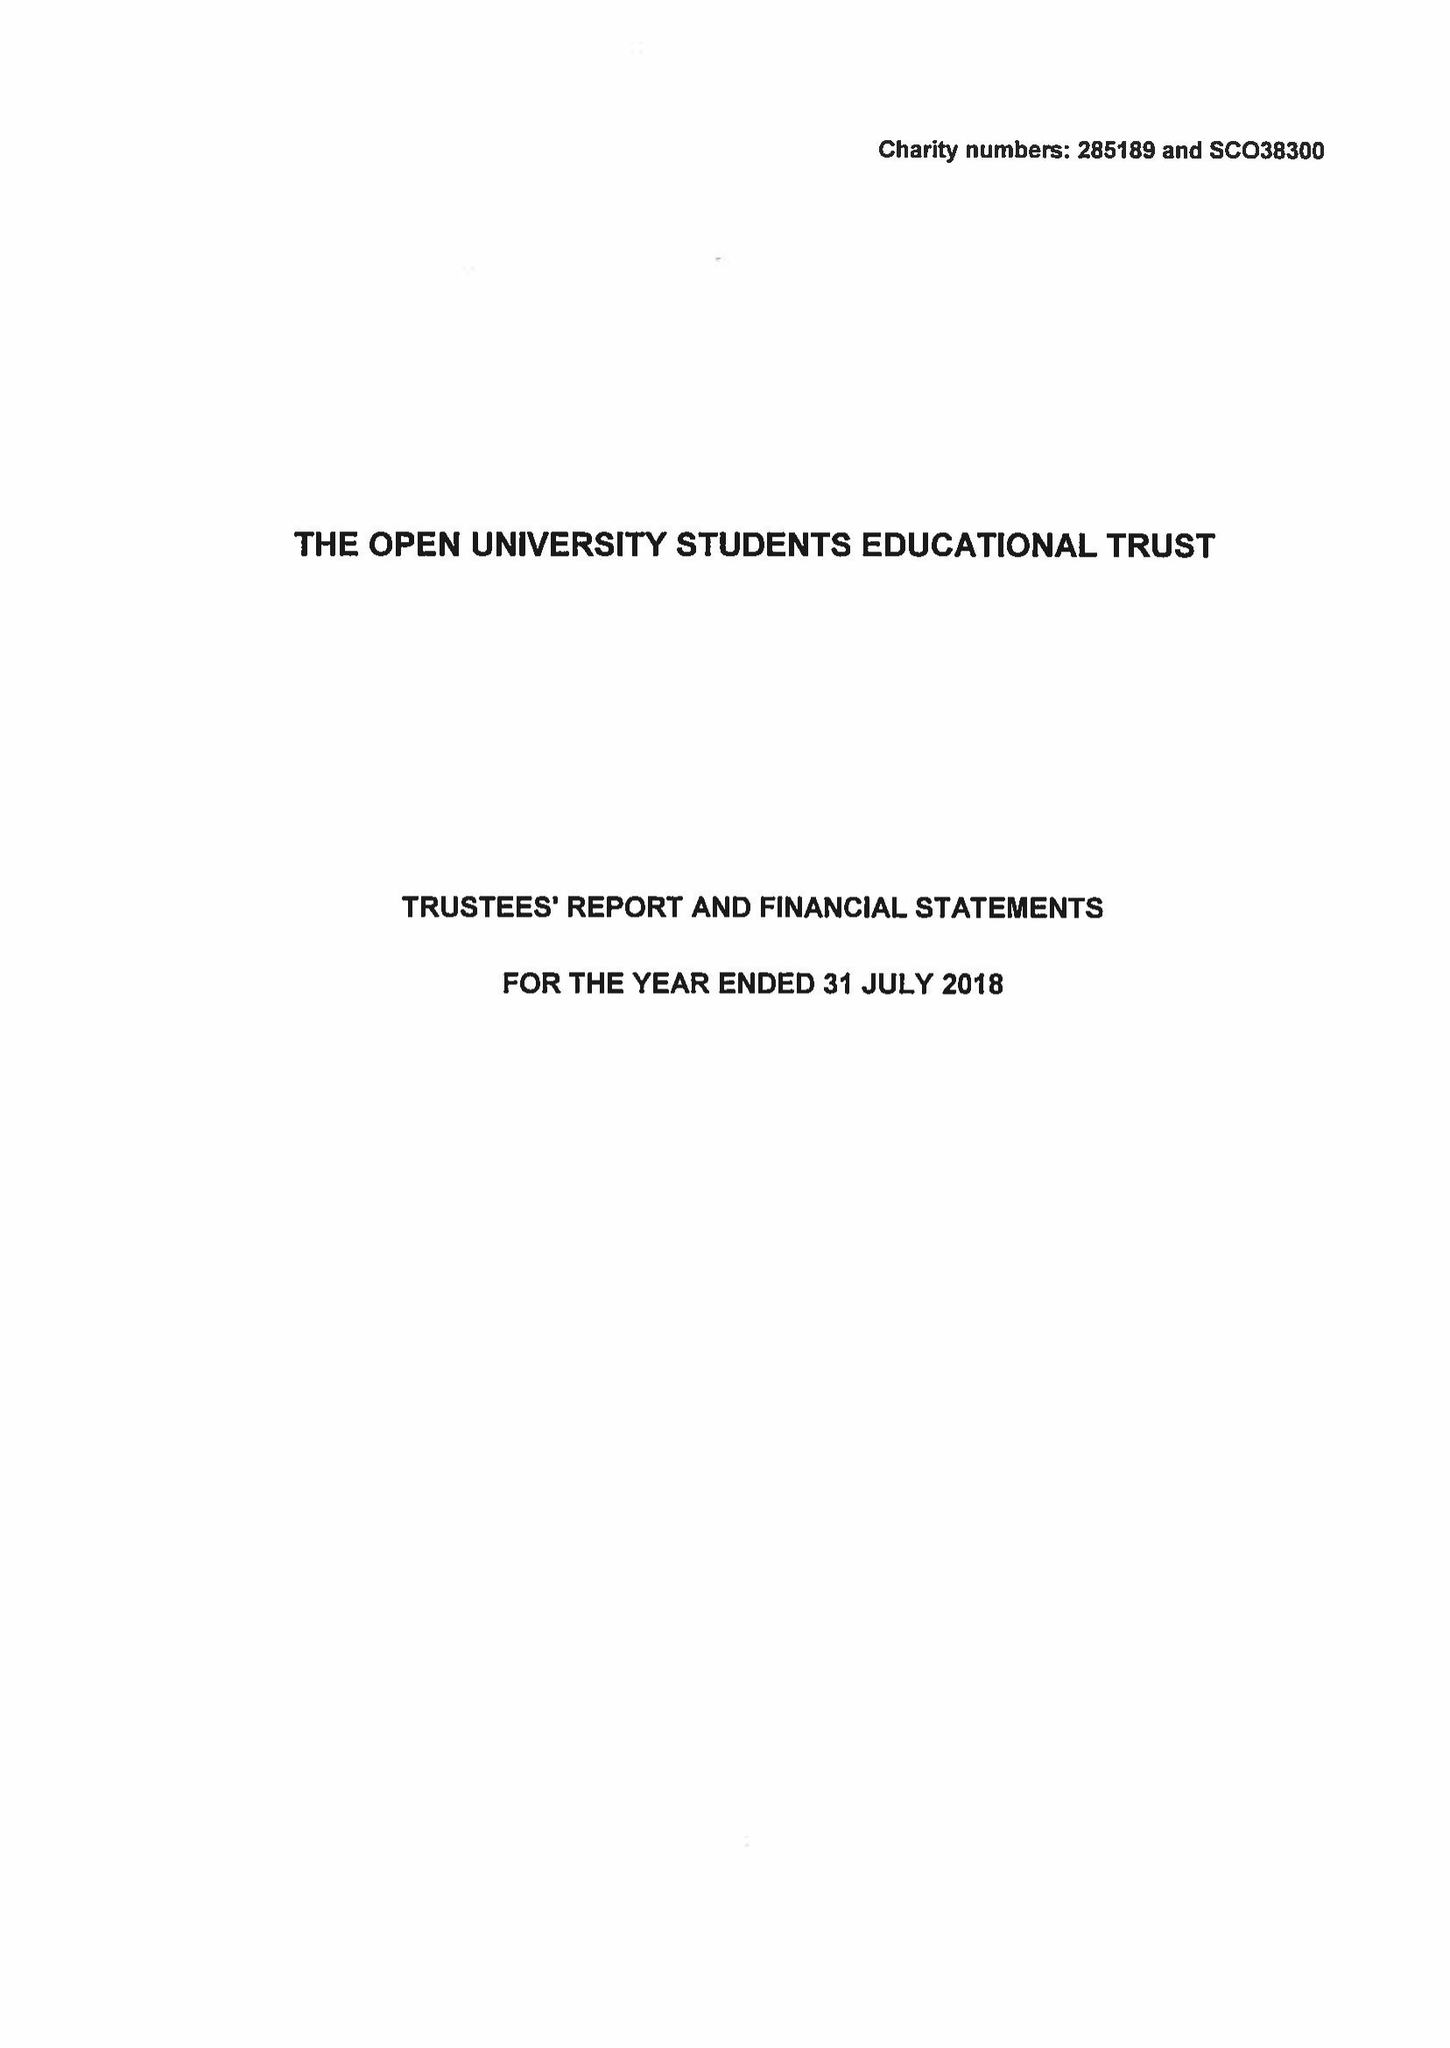What is the value for the spending_annually_in_british_pounds?
Answer the question using a single word or phrase. 325239.00 